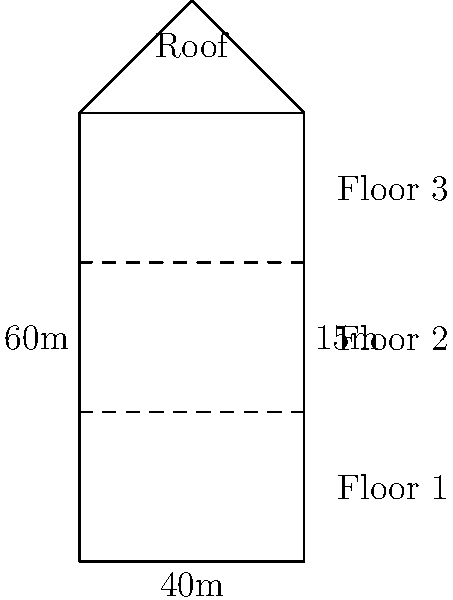As an insurance attorney, you're tasked with calculating the total surface area of a multi-story office building for insurance coverage. The building is 40m wide, 60m long, and has 3 floors, each 15m high. The roof is a simple gable design with a 5m rise from the edge to the peak. Calculate the total surface area of the building, including all external walls and the roof, to determine the appropriate insurance coverage. Let's break this down step-by-step:

1. Calculate the area of the front and back walls:
   $A_{front/back} = 40m \times 15m \times 3 floors = 1800m^2$ (each)
   Total for front and back: $1800m^2 \times 2 = 3600m^2$

2. Calculate the area of the side walls:
   $A_{side} = 60m \times 15m \times 3 floors = 2700m^2$ (each)
   Total for both sides: $2700m^2 \times 2 = 5400m^2$

3. Calculate the area of the roof:
   The roof is a gable design, so we need to calculate the slant length:
   Slant length = $\sqrt{20^2 + 5^2} = \sqrt{425} \approx 20.62m$
   Roof area = $20.62m \times 60m \times 2 sides = 2474.4m^2$

4. Sum up all the areas:
   Total surface area = Front + Back + Sides + Roof
   $= 3600m^2 + 5400m^2 + 2474.4m^2 = 11,474.4m^2$

Therefore, the total surface area of the building is approximately 11,474.4 square meters.
Answer: $11,474.4m^2$ 